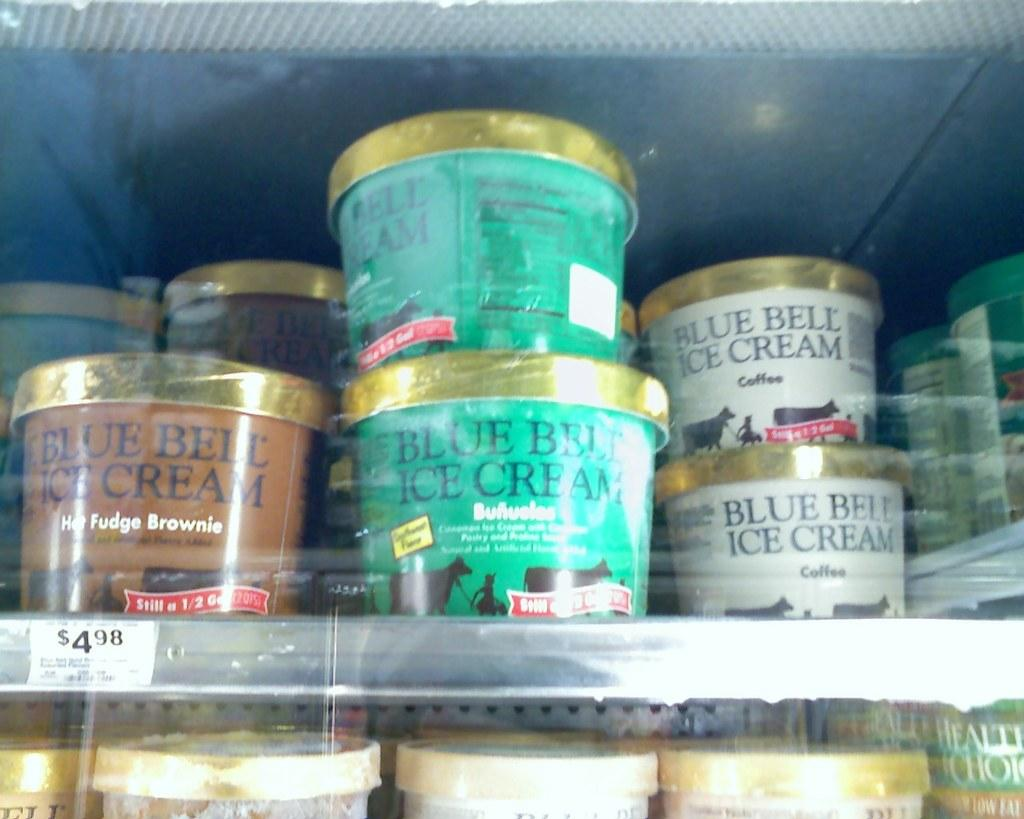What objects are visible in the image? There are boxes in the image. How are the boxes arranged? The boxes are arranged in racks. What can be found on the surface of the boxes? There is text on the boxes. Where is the playground located in the image? There is no playground present in the image; it only features boxes arranged in racks with text on them. 